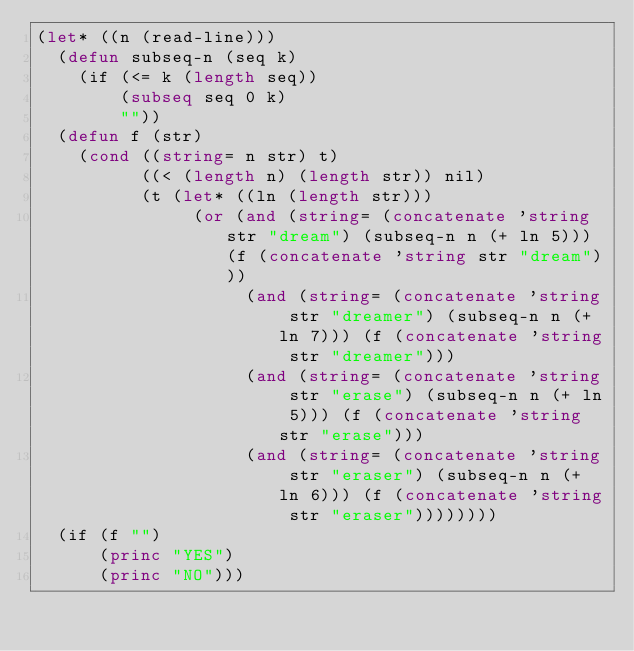<code> <loc_0><loc_0><loc_500><loc_500><_Lisp_>(let* ((n (read-line)))
  (defun subseq-n (seq k)
    (if (<= k (length seq))
        (subseq seq 0 k)
        ""))
  (defun f (str)
    (cond ((string= n str) t)
          ((< (length n) (length str)) nil)
          (t (let* ((ln (length str)))
               (or (and (string= (concatenate 'string str "dream") (subseq-n n (+ ln 5))) (f (concatenate 'string str "dream")))
                    (and (string= (concatenate 'string str "dreamer") (subseq-n n (+ ln 7))) (f (concatenate 'string str "dreamer")))
                    (and (string= (concatenate 'string str "erase") (subseq-n n (+ ln 5))) (f (concatenate 'string str "erase")))
                    (and (string= (concatenate 'string str "eraser") (subseq-n n (+ ln 6))) (f (concatenate 'string str "eraser"))))))))
  (if (f "")
      (princ "YES")
      (princ "NO")))</code> 